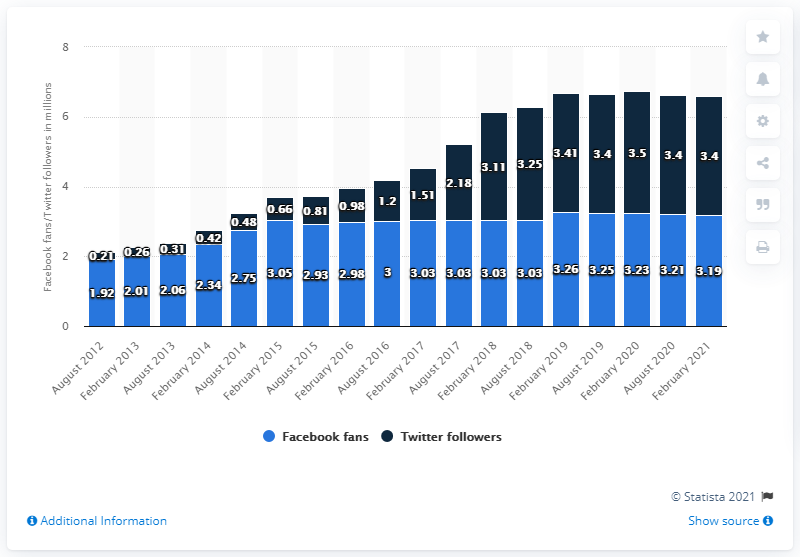Draw attention to some important aspects in this diagram. In February 2021, the number of people who were on the Facebook page of the Philadelphia Eagles was 3,190. 